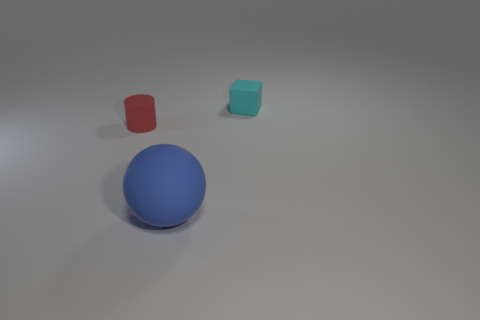There is a small block that is made of the same material as the large blue sphere; what color is it?
Your answer should be compact. Cyan. Is the shape of the big blue object the same as the small thing that is on the left side of the matte sphere?
Provide a succinct answer. No. There is a block that is the same size as the cylinder; what is it made of?
Provide a short and direct response. Rubber. Is there a big rubber object that has the same color as the small matte cylinder?
Offer a terse response. No. There is a thing that is both to the left of the cyan block and on the right side of the red cylinder; what is its shape?
Provide a short and direct response. Sphere. What number of small cyan objects have the same material as the big blue sphere?
Keep it short and to the point. 1. Is the number of tiny cylinders to the left of the blue matte sphere less than the number of big rubber spheres behind the tiny cyan matte thing?
Ensure brevity in your answer.  No. The small thing to the right of the rubber object that is in front of the small cylinder to the left of the blue matte thing is made of what material?
Keep it short and to the point. Rubber. There is a rubber object that is left of the rubber block and on the right side of the small red matte cylinder; what is its size?
Make the answer very short. Large. What number of cylinders are either large red shiny objects or tiny red things?
Keep it short and to the point. 1. 